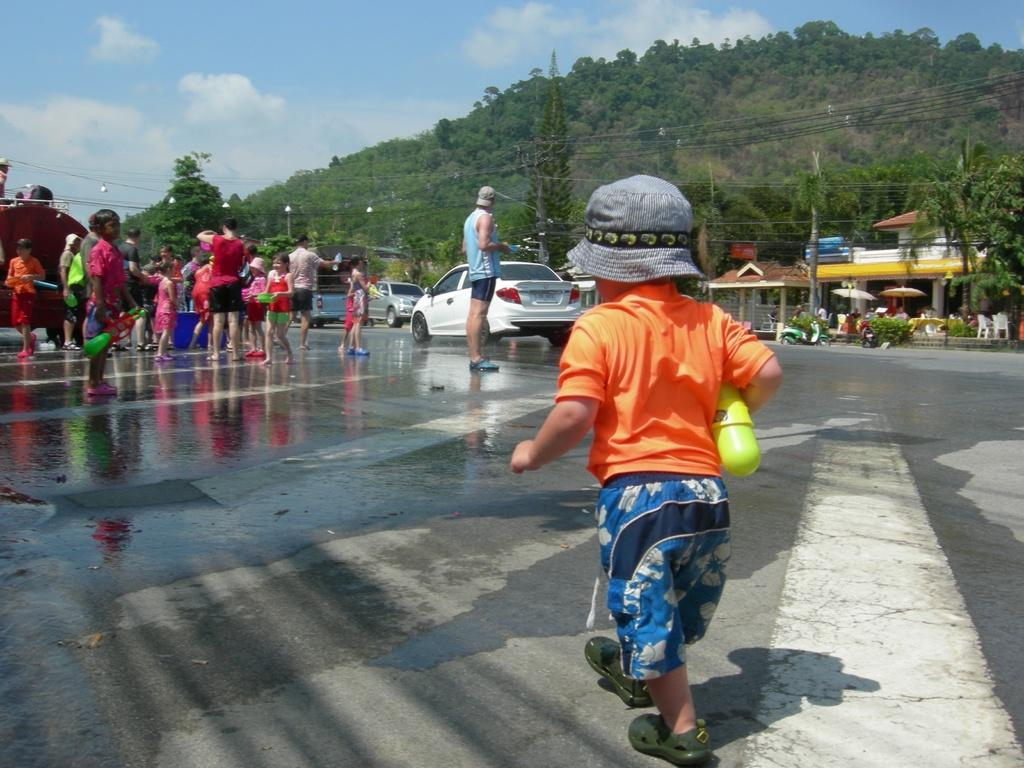Who or what can be seen in the image? There are people in the image. What else is visible on the ground in the image? There are cars on the road in the image. What can be seen in the background of the image? There is a mountain with trees in the background of the image. What type of structure is present in the image? There is a house in the image. What is visible at the top of the image? The sky is visible at the top of the image. What can be observed in the sky? Clouds are present in the sky. What type of insurance policy is being discussed by the people in the image? There is no indication in the image that the people are discussing any insurance policies. Can you tell me how many geese are flying in the sky in the image? There are no geese present in the image; only clouds can be observed in the sky. 